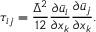Convert formula to latex. <formula><loc_0><loc_0><loc_500><loc_500>\tau _ { i j } = \frac { \bar { \Delta } ^ { 2 } } { 1 2 } \frac { \partial \bar { u } _ { i } } { \partial x _ { k } } \frac { \partial \bar { u } _ { j } } { \partial x _ { k } } .</formula> 